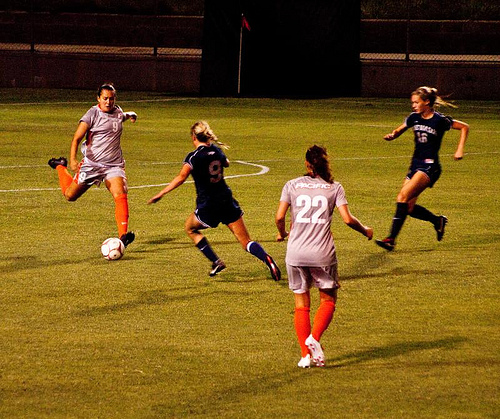<image>
Is the football on the ground? Yes. Looking at the image, I can see the football is positioned on top of the ground, with the ground providing support. Where is the ball in relation to the girl? Is it behind the girl? No. The ball is not behind the girl. From this viewpoint, the ball appears to be positioned elsewhere in the scene. 